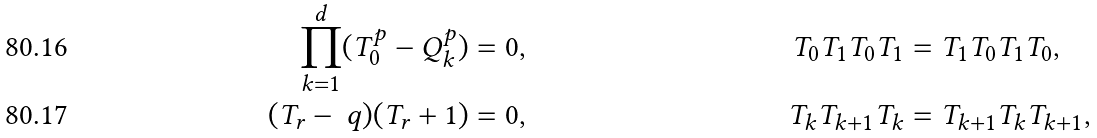Convert formula to latex. <formula><loc_0><loc_0><loc_500><loc_500>\prod _ { k = 1 } ^ { d } ( T _ { 0 } ^ { p } - Q _ { k } ^ { p } ) & = 0 , & T _ { 0 } T _ { 1 } T _ { 0 } T _ { 1 } & = T _ { 1 } T _ { 0 } T _ { 1 } T _ { 0 } , \\ ( T _ { r } - \ q ) ( T _ { r } + 1 ) & = 0 , & T _ { k } T _ { k + 1 } T _ { k } & = T _ { k + 1 } T _ { k } T _ { k + 1 } ,</formula> 